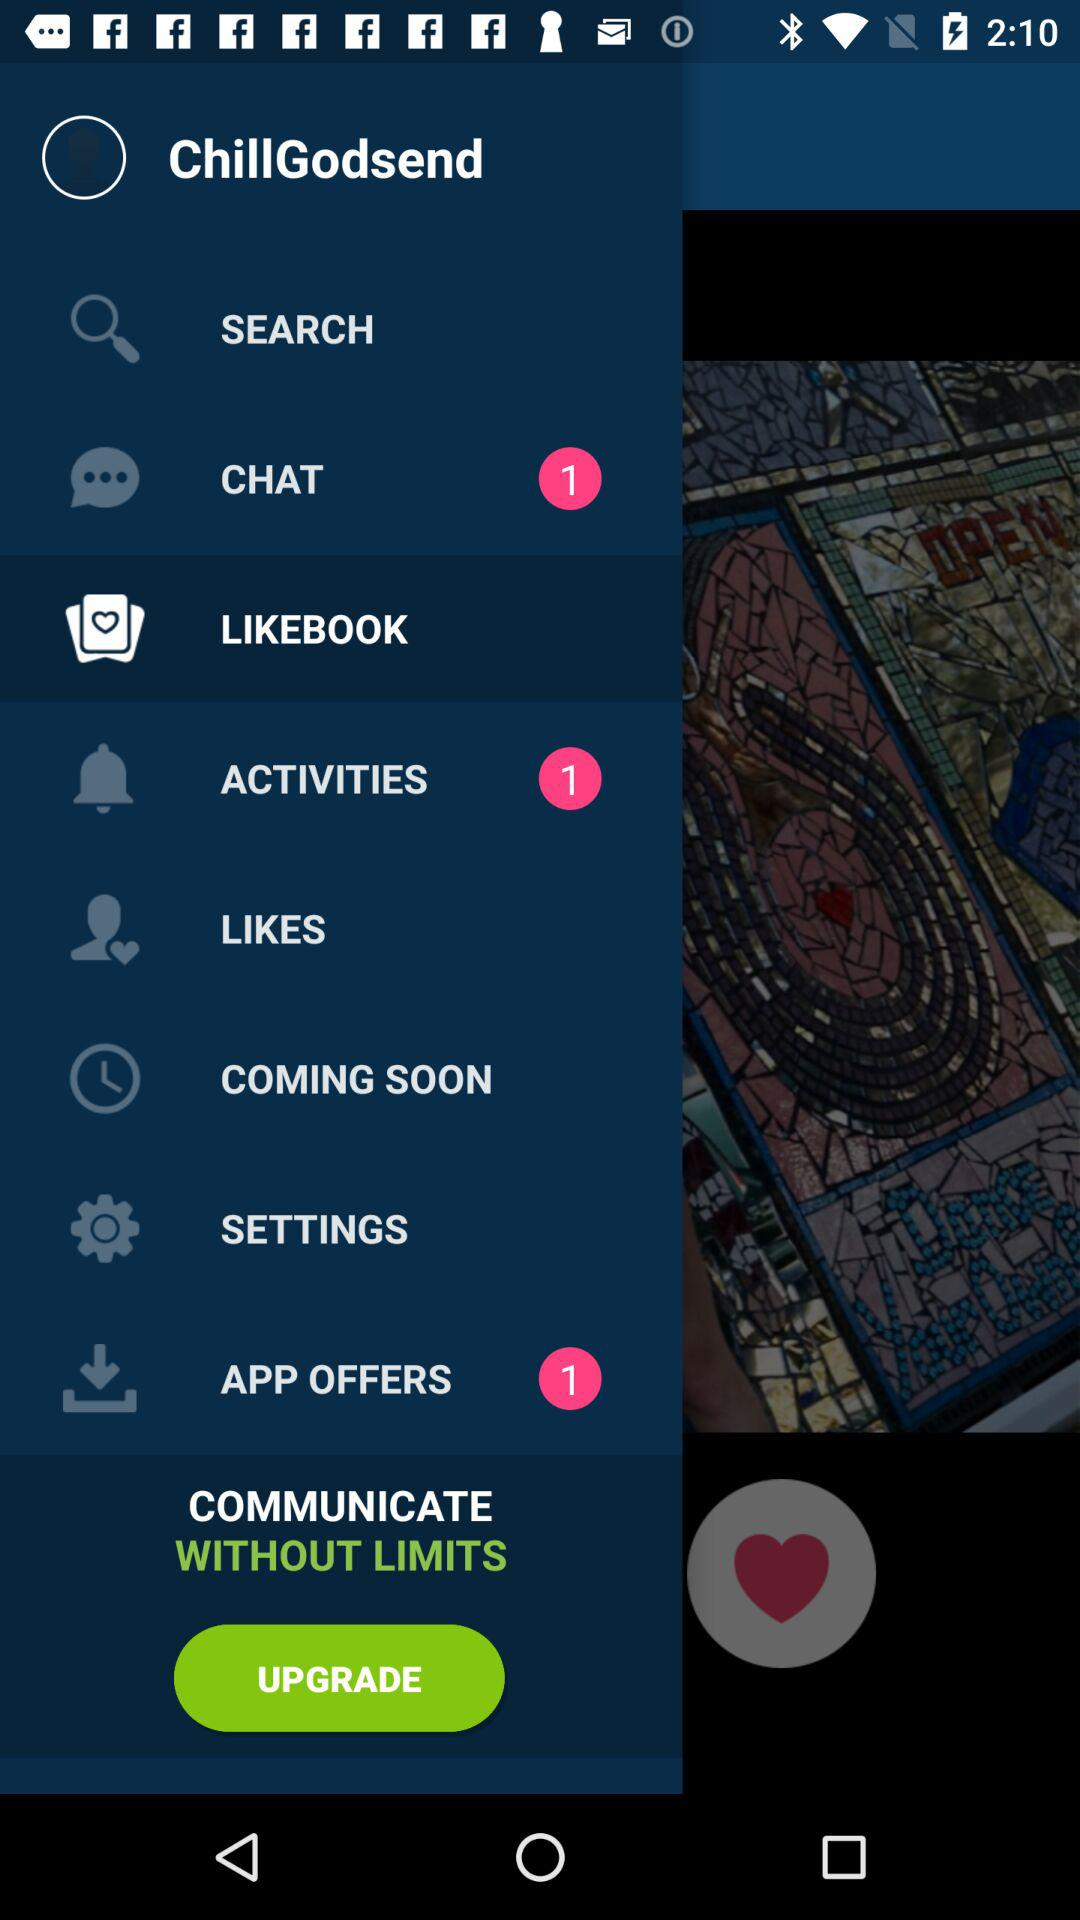What is the number of unread notifications in activities? The number of unread notifications in activities is 1. 